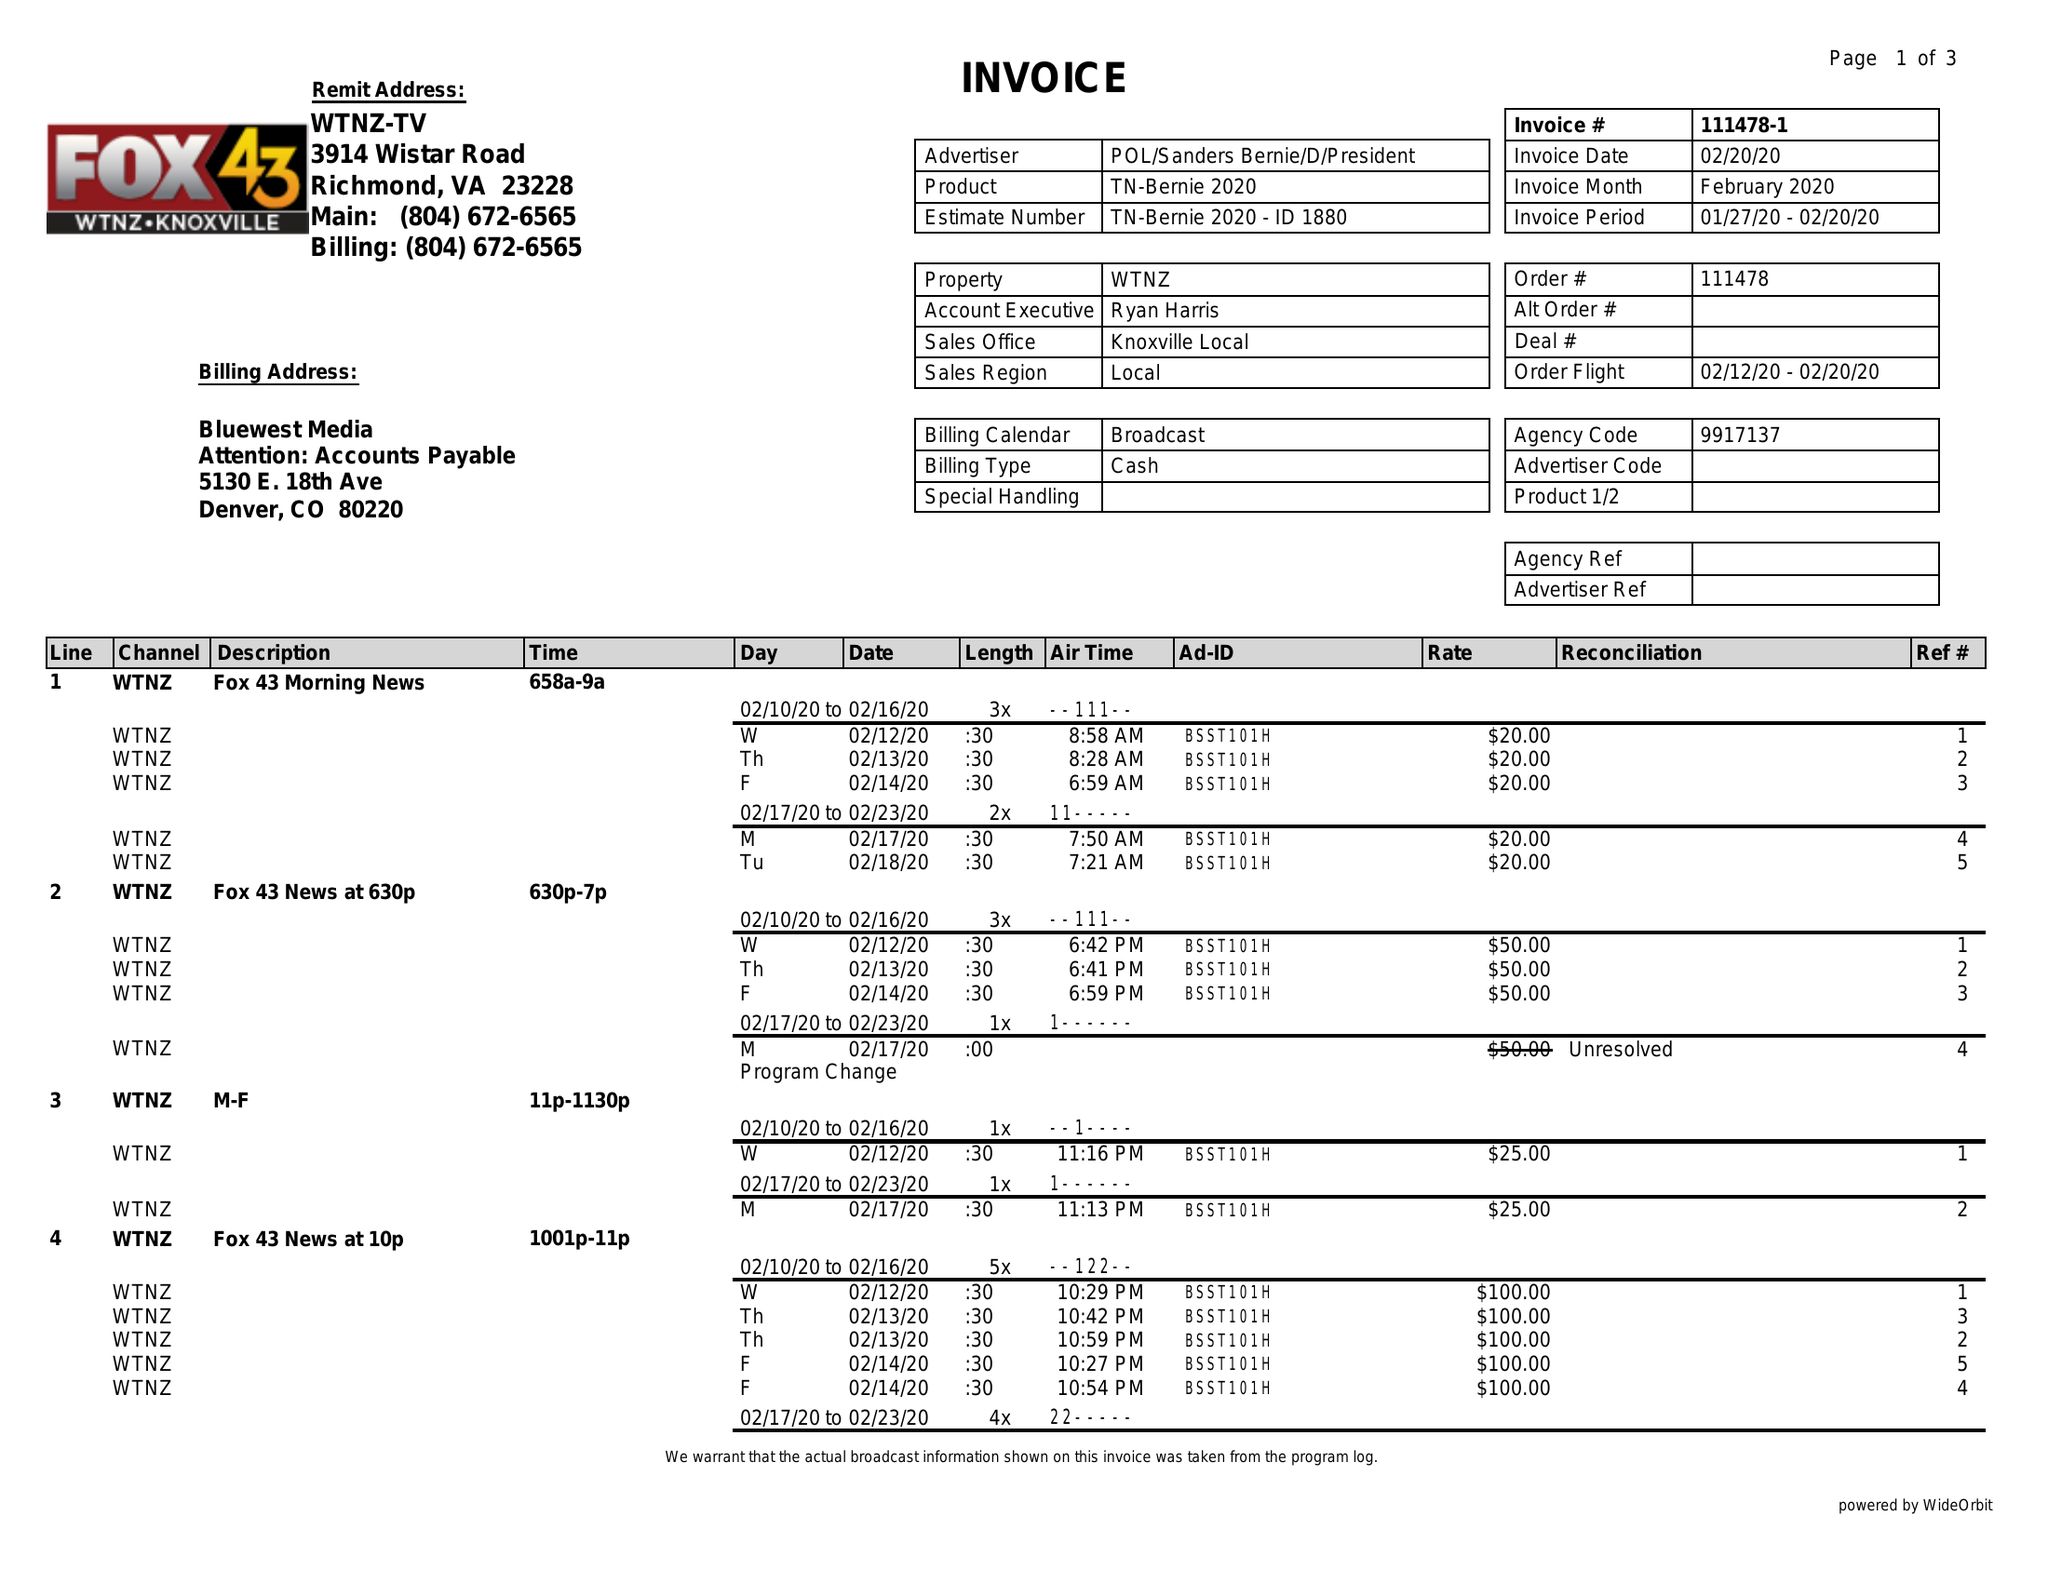What is the value for the gross_amount?
Answer the question using a single word or phrase. 1720.00 